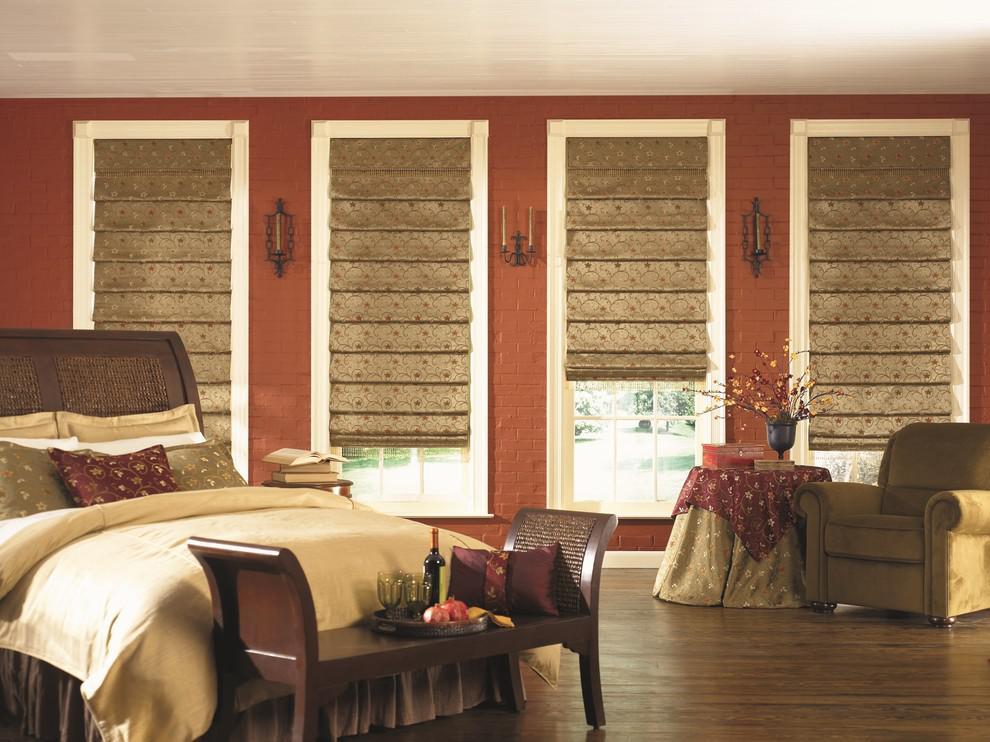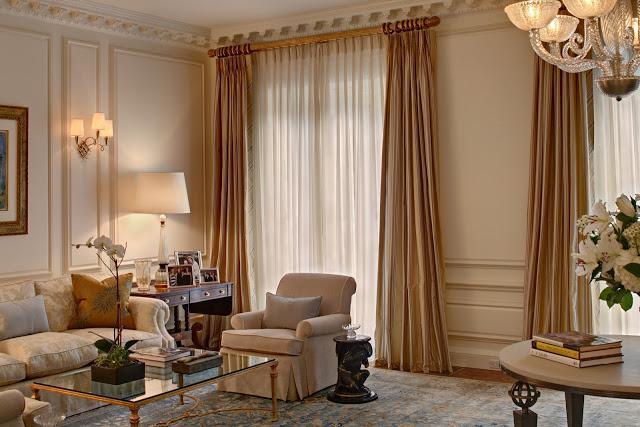The first image is the image on the left, the second image is the image on the right. For the images shown, is this caption "An image shows a room with dark-colored walls and at least four brown shades on windows with light-colored frames and no drapes." true? Answer yes or no. Yes. The first image is the image on the left, the second image is the image on the right. Given the left and right images, does the statement "Shades are at least partially open in both images." hold true? Answer yes or no. No. 